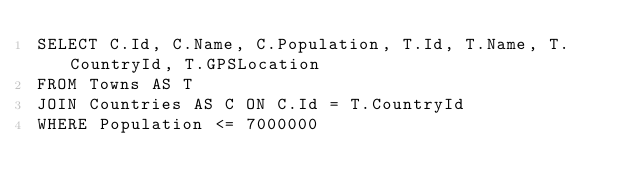<code> <loc_0><loc_0><loc_500><loc_500><_SQL_>SELECT C.Id, C.Name, C.Population, T.Id, T.Name, T.CountryId, T.GPSLocation
FROM Towns AS T
JOIN Countries AS C ON C.Id = T.CountryId
WHERE Population <= 7000000</code> 